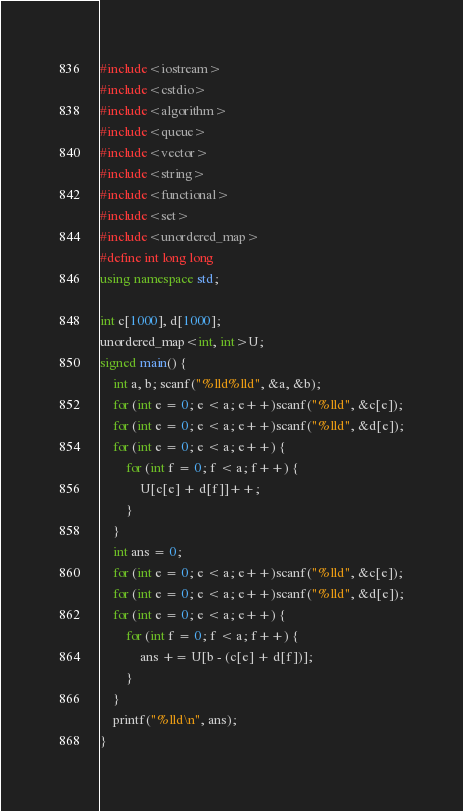<code> <loc_0><loc_0><loc_500><loc_500><_C++_>#include<iostream>
#include<cstdio>
#include<algorithm>
#include<queue>
#include<vector>
#include<string>
#include<functional>
#include<set>
#include<unordered_map>
#define int long long
using namespace std;

int c[1000], d[1000];
unordered_map<int, int>U;
signed main() {
	int a, b; scanf("%lld%lld", &a, &b);
	for (int e = 0; e < a; e++)scanf("%lld", &c[e]);
	for (int e = 0; e < a; e++)scanf("%lld", &d[e]);
	for (int e = 0; e < a; e++) {
		for (int f = 0; f < a; f++) {
			U[c[e] + d[f]]++;
		}
	}
	int ans = 0;
	for (int e = 0; e < a; e++)scanf("%lld", &c[e]);
	for (int e = 0; e < a; e++)scanf("%lld", &d[e]);
	for (int e = 0; e < a; e++) {
		for (int f = 0; f < a; f++) {
			ans += U[b - (c[e] + d[f])];
		}
	}
	printf("%lld\n", ans);
}</code> 